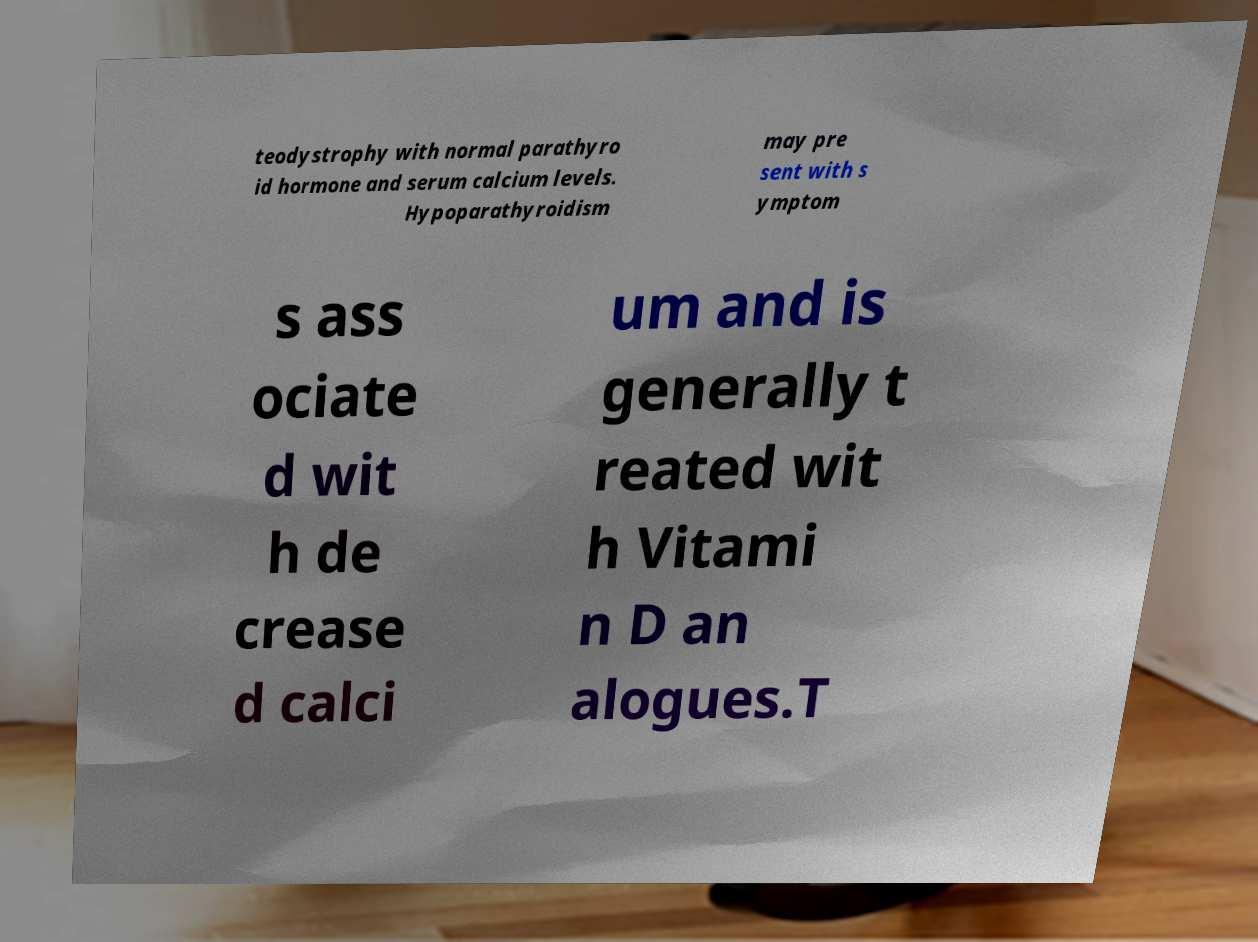Please identify and transcribe the text found in this image. teodystrophy with normal parathyro id hormone and serum calcium levels. Hypoparathyroidism may pre sent with s ymptom s ass ociate d wit h de crease d calci um and is generally t reated wit h Vitami n D an alogues.T 